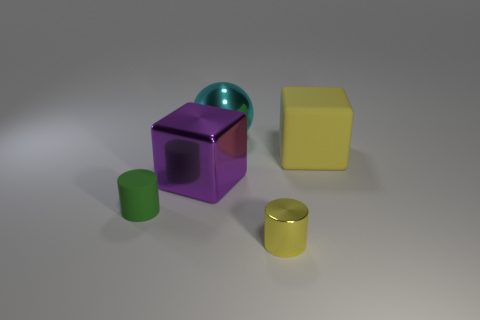Are there any other things that have the same color as the small rubber cylinder?
Make the answer very short. No. Do the matte object behind the green object and the metal object in front of the metallic cube have the same color?
Offer a very short reply. Yes. Is the number of big cubes on the left side of the big yellow rubber cube greater than the number of small yellow cylinders that are left of the tiny green thing?
Your answer should be very brief. Yes. What is the material of the purple block?
Provide a succinct answer. Metal. What is the shape of the rubber object that is left of the big block on the right side of the tiny cylinder that is right of the green object?
Provide a short and direct response. Cylinder. What number of other things are the same material as the green cylinder?
Provide a short and direct response. 1. Is the big thing in front of the big yellow block made of the same material as the tiny cylinder that is right of the small rubber cylinder?
Make the answer very short. Yes. What number of objects are on the right side of the rubber cylinder and on the left side of the large yellow matte cube?
Make the answer very short. 3. Is there another large thing of the same shape as the green thing?
Offer a terse response. No. The yellow object that is the same size as the cyan shiny ball is what shape?
Make the answer very short. Cube. 